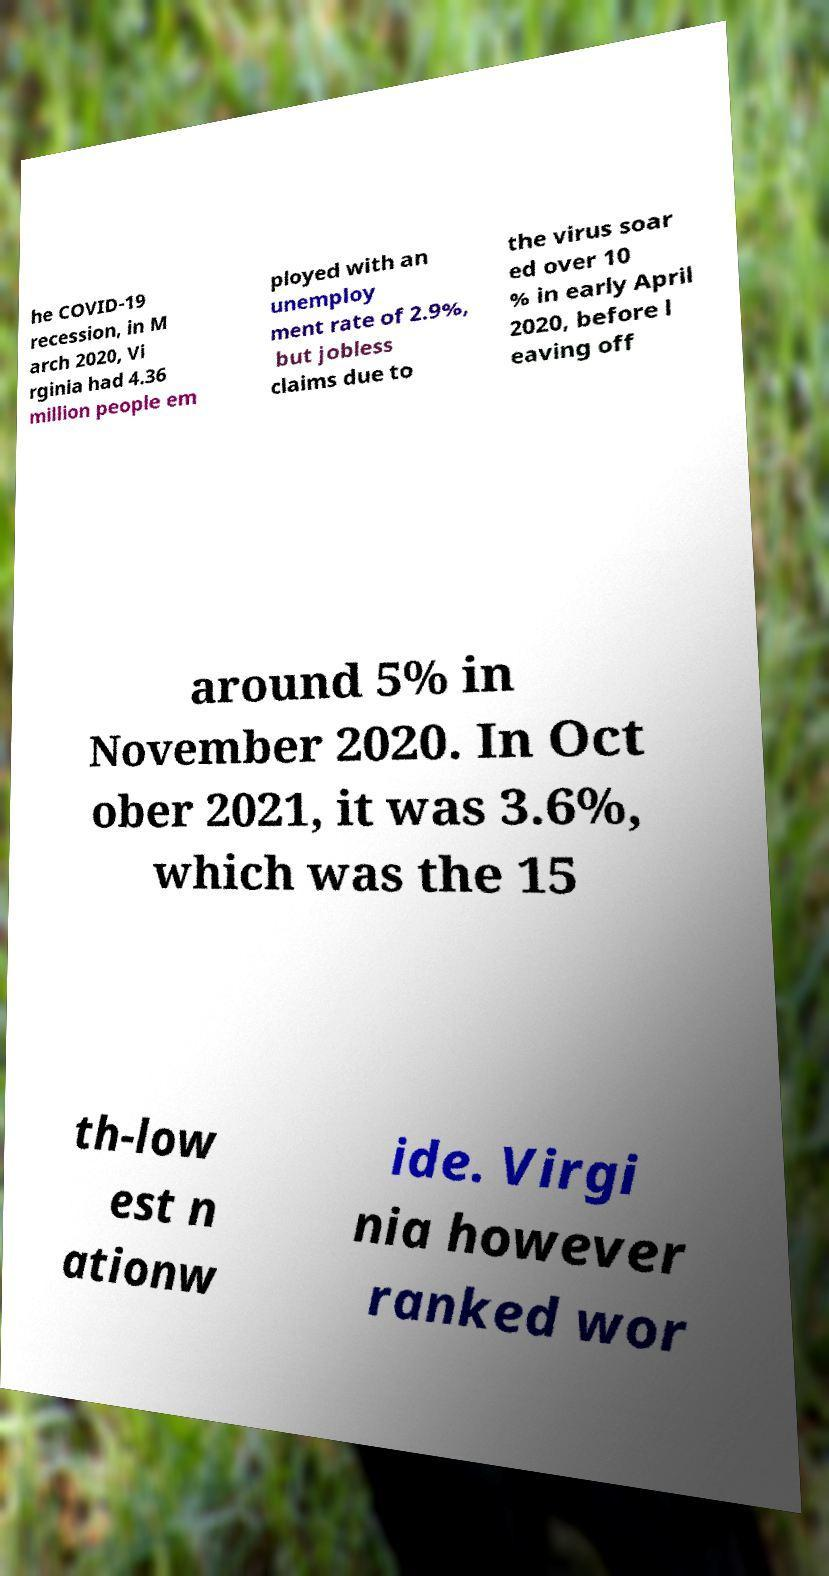Please read and relay the text visible in this image. What does it say? he COVID-19 recession, in M arch 2020, Vi rginia had 4.36 million people em ployed with an unemploy ment rate of 2.9%, but jobless claims due to the virus soar ed over 10 % in early April 2020, before l eaving off around 5% in November 2020. In Oct ober 2021, it was 3.6%, which was the 15 th-low est n ationw ide. Virgi nia however ranked wor 